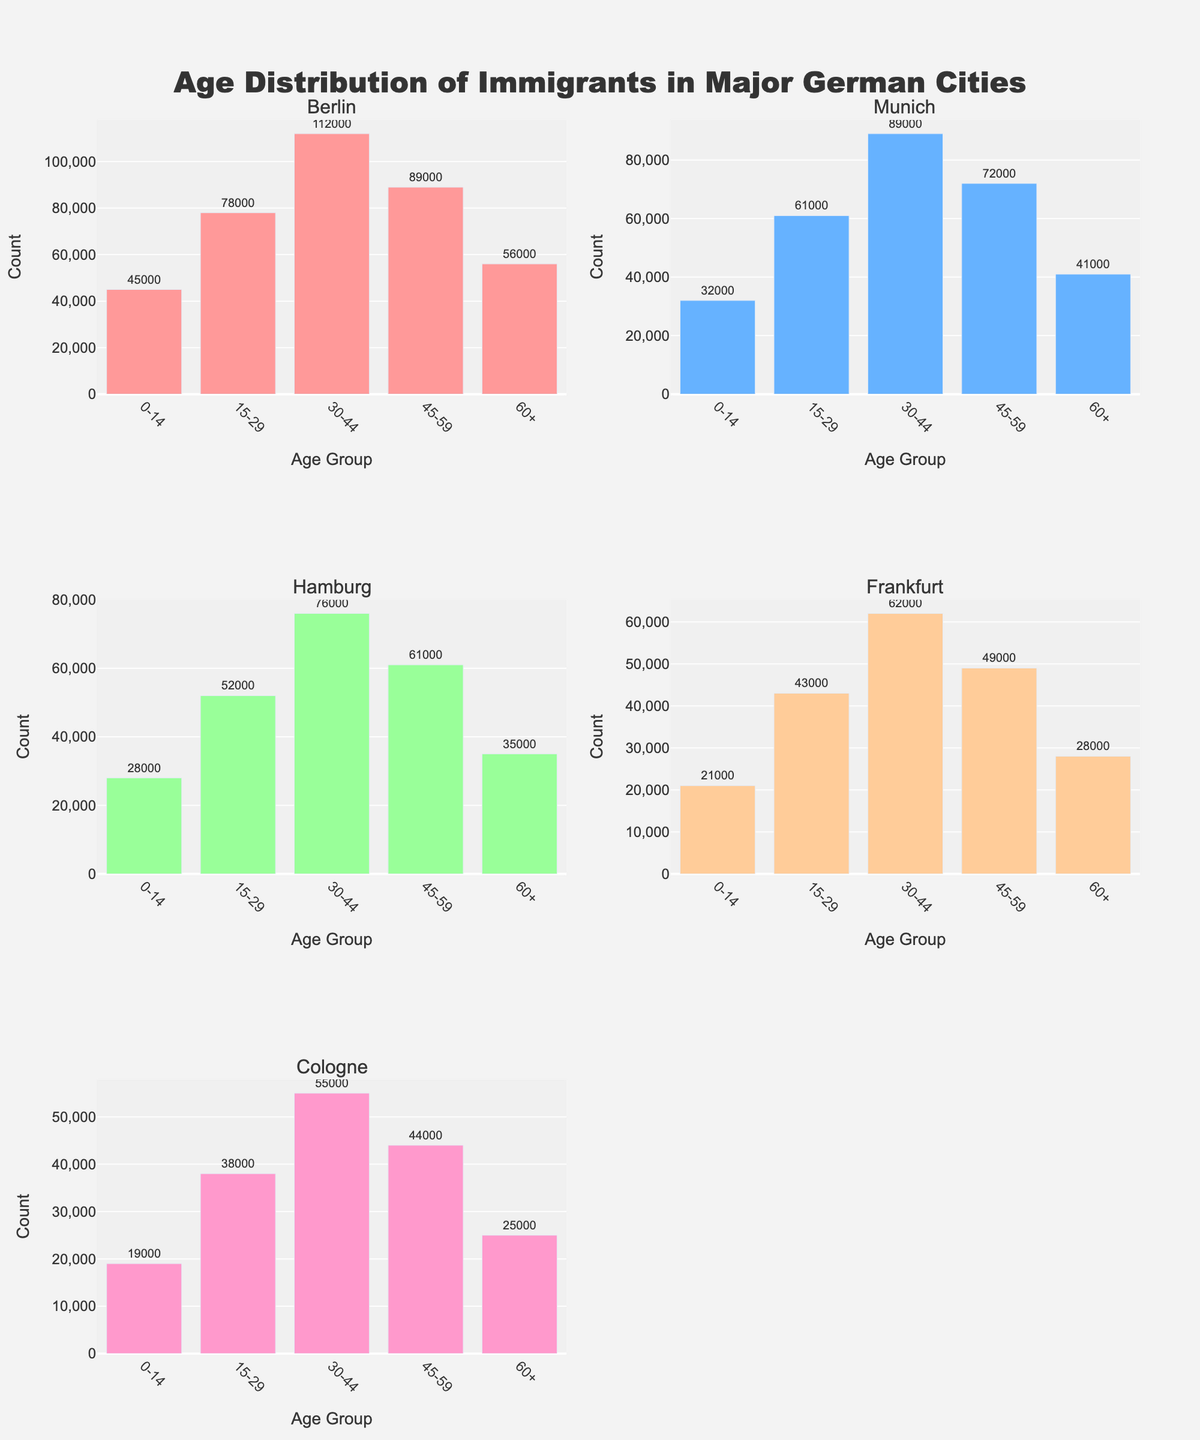Which city shows the highest count for the age group 30-44? By examining the figure, we can observe each city’s histogram and identify which city bar has the highest count for the age group 30-44. Berlin's histogram shows the highest bar in this age group.
Answer: Berlin Which city has the lowest count for the age group 0-14? By looking at the histogram bars corresponding to the 0-14 age group in each city's subplot, we can see that Cologne has the lowest count for this age group.
Answer: Cologne What is the total count of immigrants aged 15-29 in Hamburg and Munich? Summing up the counts of the 15-29 age group for both cities from the respective histograms will give us the total count. Hamburg has 52,000 and Munich has 61,000 immigrants in this age group. So the total is 52,000 + 61,000 = 113,000.
Answer: 113,000 How many cities have more immigrants in the age group 45-59 than in the age group 60+? By comparing the counts of the 45-59 and 60+ age groups in each histogram, we see that Berlin, Munich, Hamburg, Frankfurt, and Cologne all have higher counts in the 45-59 age group than in the 60+ age group. Thus, all five cities fit this criterion.
Answer: 5 Which age group has the highest count in Frankfurt? By observing Frankfurt's histogram, we can identify the highest bar, which belongs to the 30-44 age group.
Answer: 30-44 In which city is the difference between the counts of the age groups 30-44 and 0-14 the largest? To find this city, compute the differences between the counts of age groups 30-44 and 0-14 for each city. The differences are Berlin (112,000 - 45,000 = 67,000), Munich (89,000 - 32,000 = 57,000), Hamburg (76,000 - 28,000 = 48,000), Frankfurt (62,000 - 21,000 = 41,000), and Cologne (55,000 - 19,000 = 36,000). The largest difference is in Berlin.
Answer: Berlin Which age group has the lowest count in Munich? In Munich's histogram, the lowest bar corresponds to the 60+ age group.
Answer: 60+ Are there more immigrants aged 0-14 in Berlin or Hamburg? By comparing the heights of the bars for the age group 0-14 in Berlin and Hamburg, we see that Berlin has more immigrants in this age group (45,000 vs. 28,000).
Answer: Berlin 